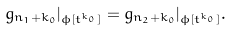Convert formula to latex. <formula><loc_0><loc_0><loc_500><loc_500>g _ { n _ { 1 } + k _ { 0 } } | _ { \phi [ t ^ { k _ { 0 } } ] } = g _ { n _ { 2 } + k _ { 0 } } | _ { \phi [ t ^ { k _ { 0 } } ] } .</formula> 